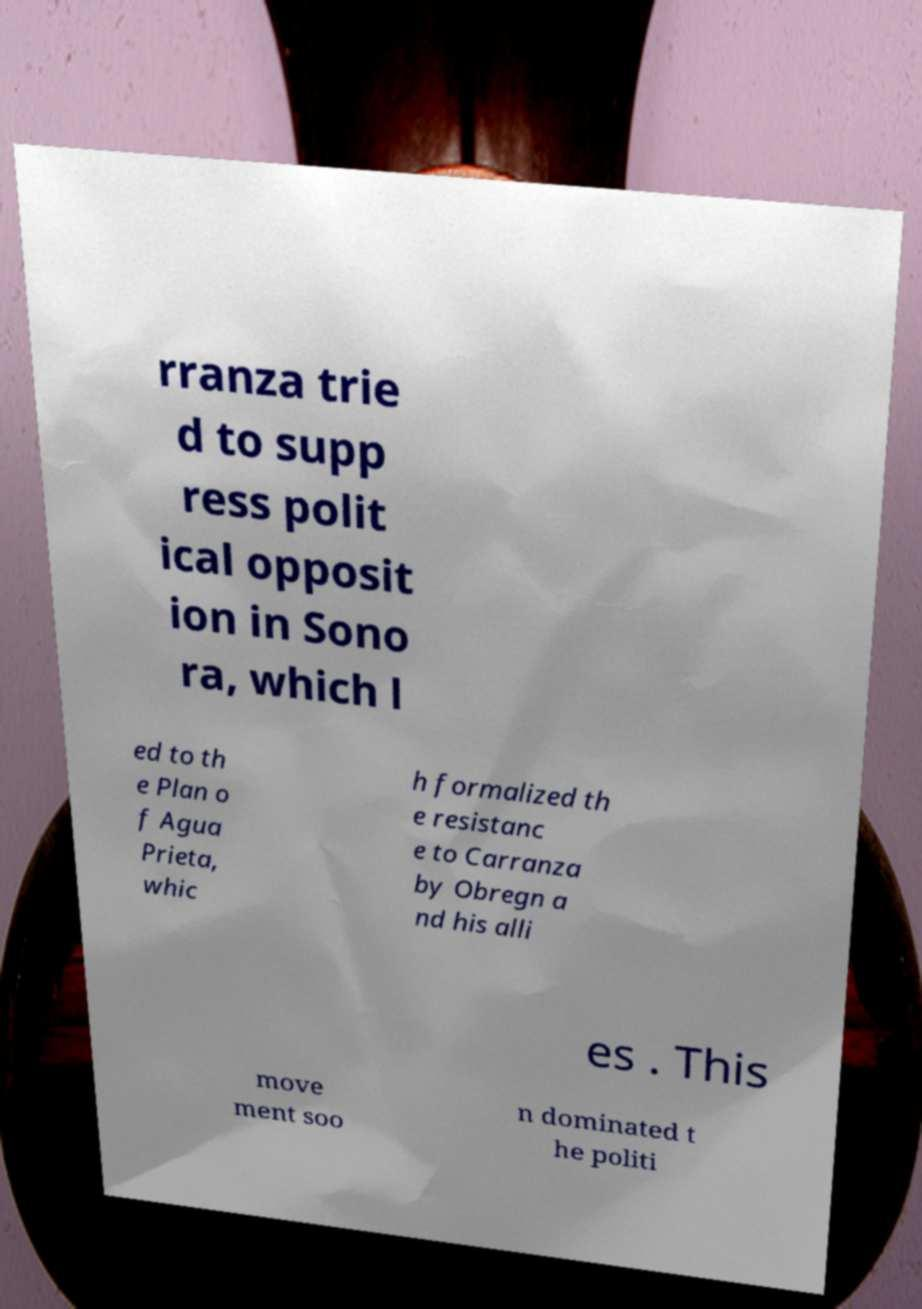Could you extract and type out the text from this image? rranza trie d to supp ress polit ical opposit ion in Sono ra, which l ed to th e Plan o f Agua Prieta, whic h formalized th e resistanc e to Carranza by Obregn a nd his alli es . This move ment soo n dominated t he politi 